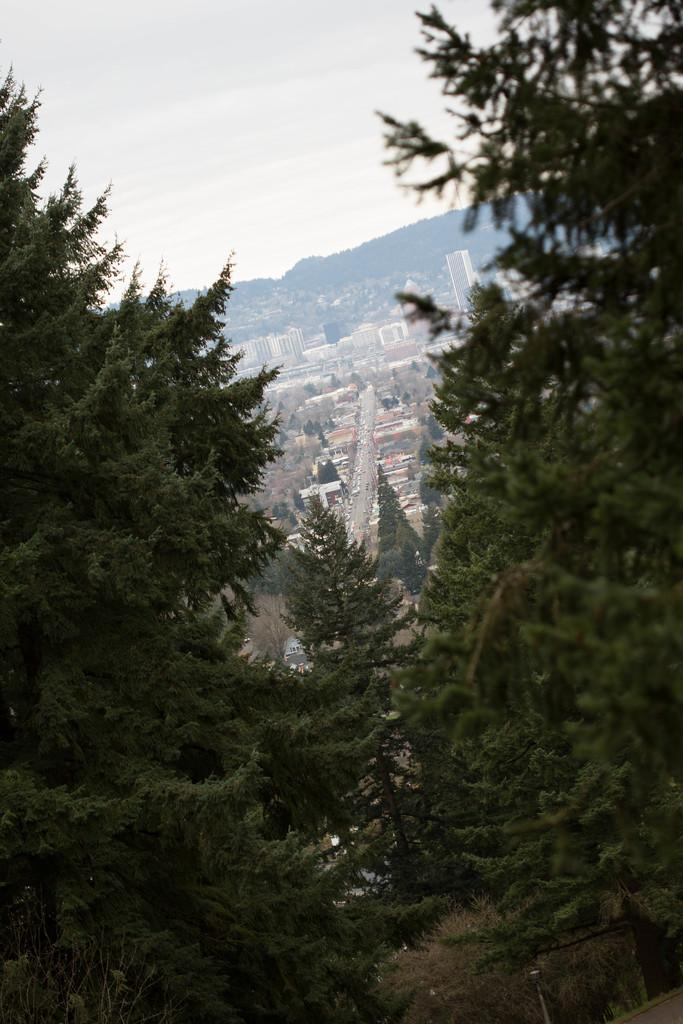What type of natural elements can be seen in the image? There are trees in the image. What type of man-made structures are present in the image? There are buildings at the center of the image. What type of geographical features can be seen in the image? There are mountains in the image. What is visible in the background of the image? The sky is visible in the background of the image. What is the name of the competition taking place in the image? There is no competition present in the image. Can you see a rifle in the image? There is no rifle present in the image. 